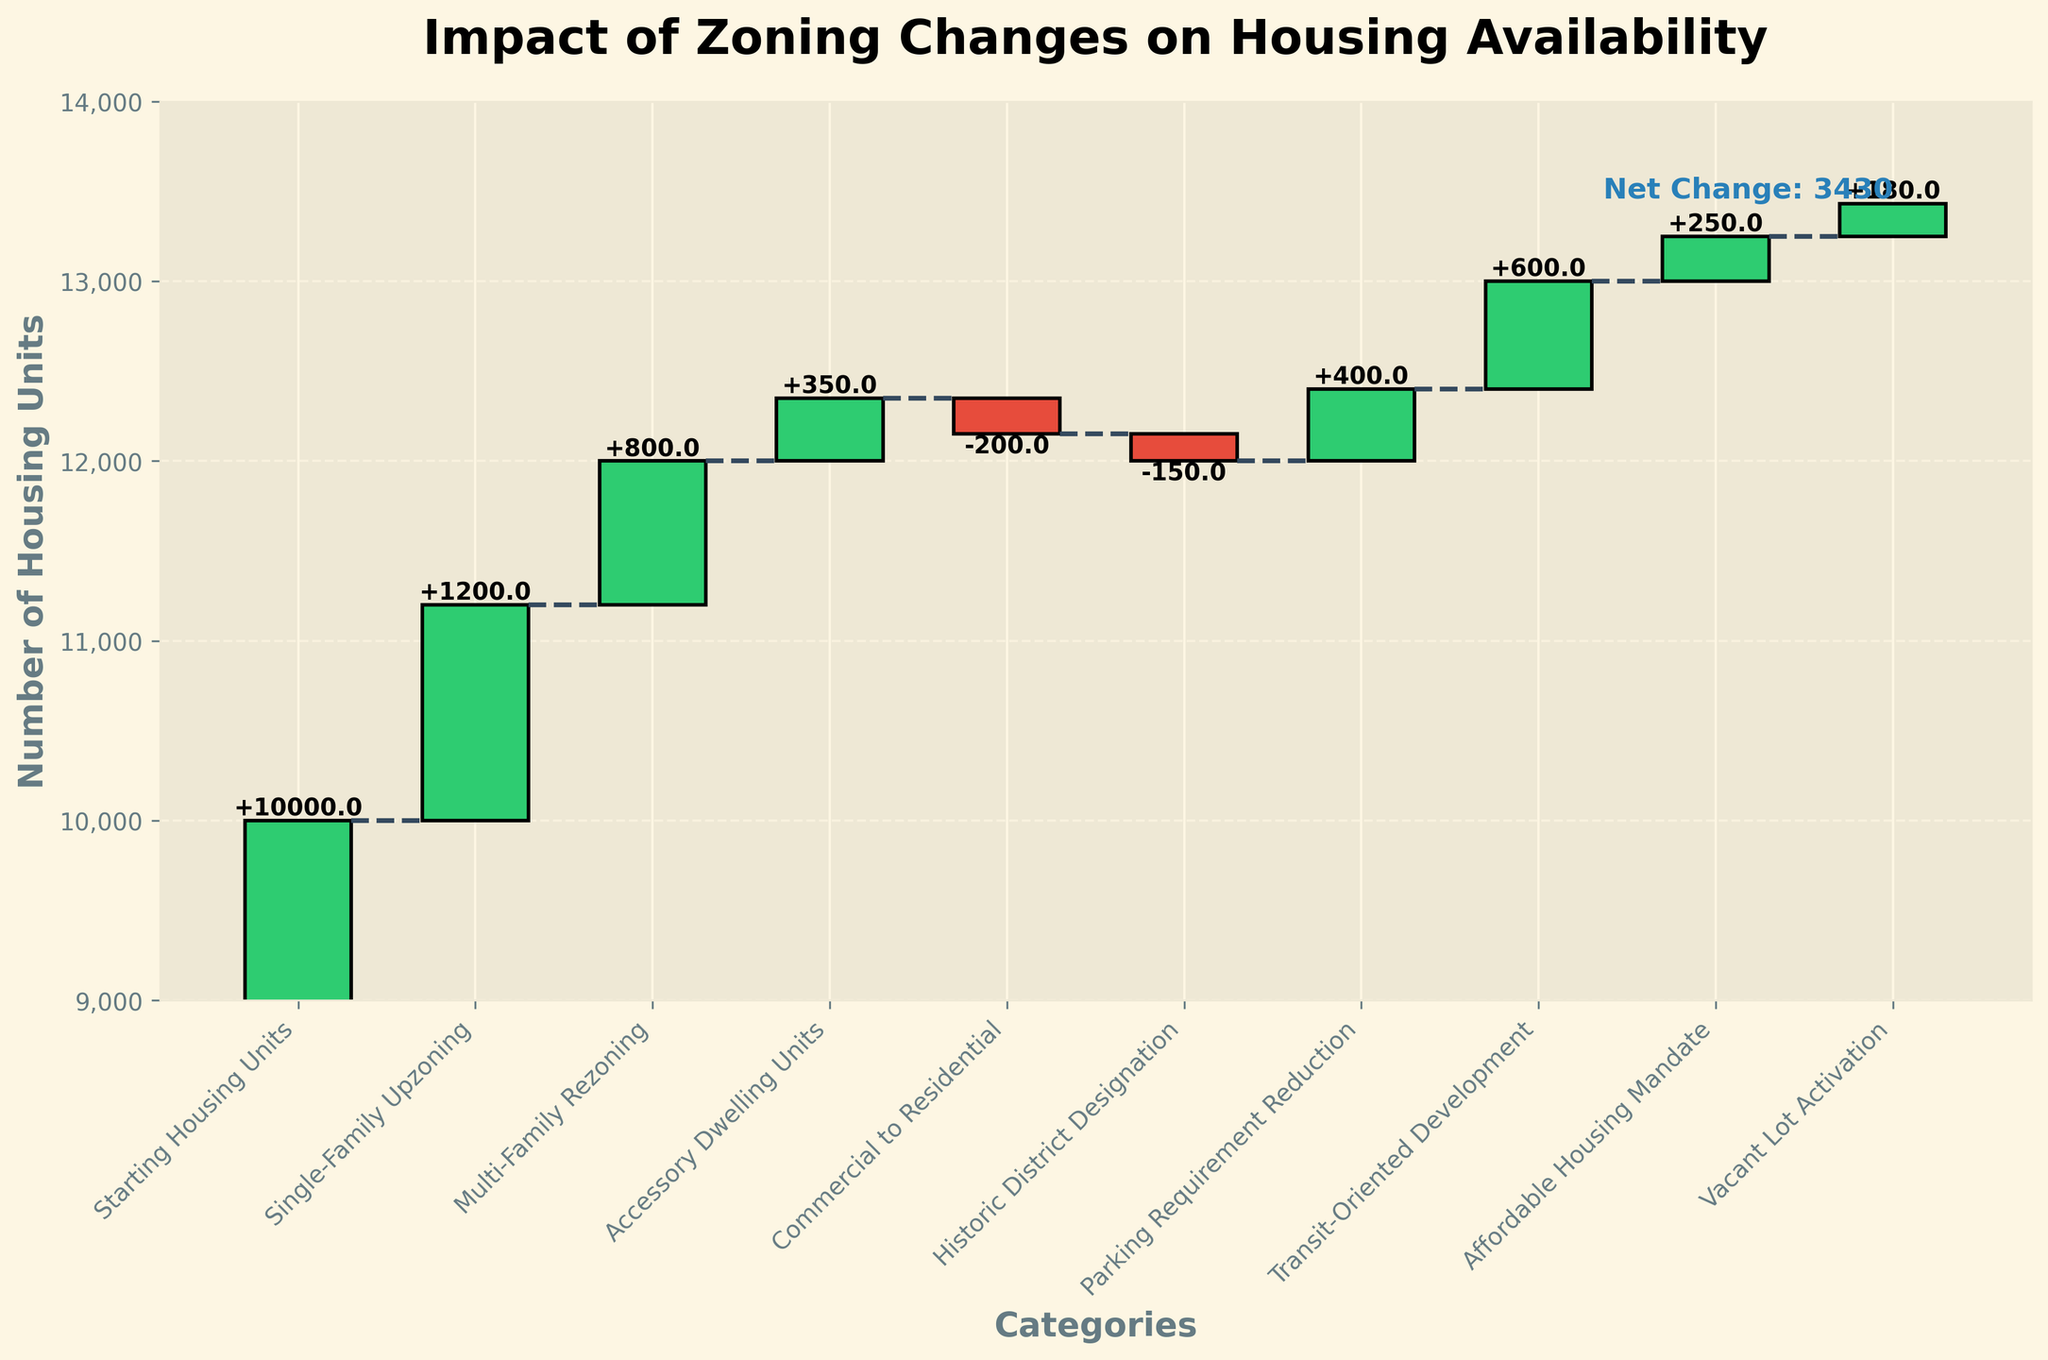How many categories result in a decrease in housing units? First, identify the categories with negative values, which are "Commercial to Residential" and "Historic District Designation". Count these categories.
Answer: 2 What is the net change in housing units after all the zoning changes? The net change is presented directly in the figure by summing up all gains and losses. It's provided as a specific data point in the chart.
Answer: 3430 Which zoning change had the largest positive impact on housing availability? Compare the positive values. "Single-Family Upzoning" has the highest positive value of +1200.
Answer: Single-Family Upzoning What is the cumulative housing unit count after "Accessory Dwelling Units" are included? The cumulative effect after "Accessory Dwelling Units" is the sum of "Starting Housing Units" and all the preceding changes up to this point. Calculate 10000 + 1200 + 800 + 350 = 12350.
Answer: 12350 Which zoning change offset the reduction from the "Commercial to Residential" conversion completely? The decrease from "Commercial to Residential" is offset by "Parking Requirement Reduction", with values -200 and +400 respectively, making the overall impact positive.
Answer: Parking Requirement Reduction How do "Transit-Oriented Development" and "Affordable Housing Mandate" together impact housing availability? Add the individual impacts of both changes: +600 (Transit-Oriented Development) and +250 (Affordable Housing Mandate) to find the combined impact. 600 + 250 = 850.
Answer: 850 What is the final number of housing units after all changes are applied? Start with the "Starting Housing Units" (10,000) and add the net change (+3430). This is directly given in the chart as the "Ending Housing Units".
Answer: 13,430 How does the introduction of "Historic District Designation" affect the availability of housing units? Identify the impact value for "Historic District Designation", which is -150, indicating a reduction in housing units.
Answer: -150 Are there more zoning changes resulting in an increase or decrease in housing units? Count the categories with positive values and those with negative values. There are more categories with positive values (7) than negative (2).
Answer: Increase Which zoning change had the smallest positive impact on housing availability? Compare the positive values and identify the smallest, which is "Vacant Lot Activation" with a value of +180.
Answer: Vacant Lot Activation 